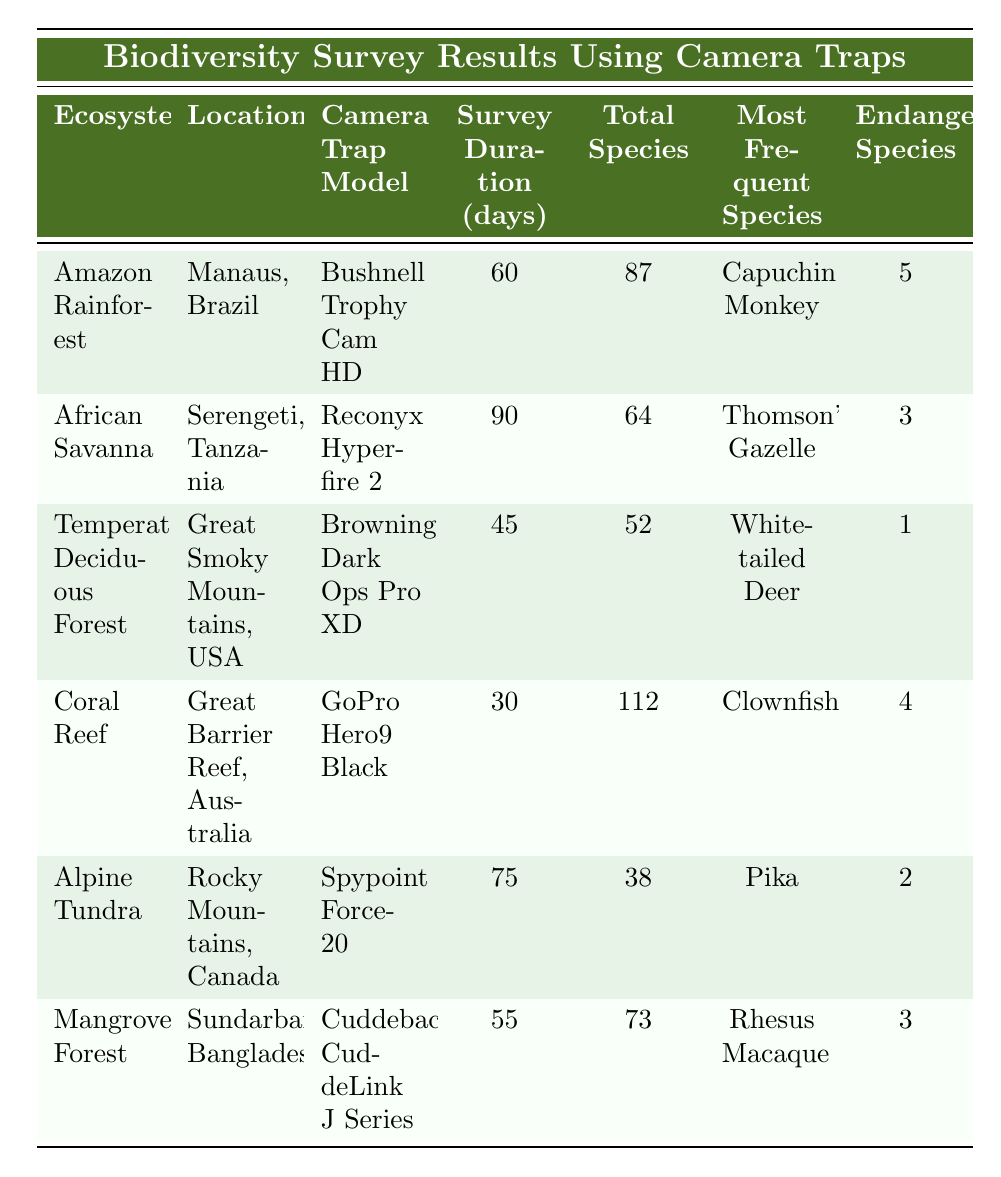What is the total number of species captured in the Coral Reef ecosystem? According to the table, in the Coral Reef ecosystem, the total species captured is listed as 112.
Answer: 112 Which ecosystem had the shortest survey duration? The survey duration for the Alpine Tundra is 75 days, but the Temperate Deciduous Forest had only 45 days, which is the shortest.
Answer: Temperate Deciduous Forest How many endangered species were observed in the Amazon Rainforest? The table states that 5 endangered species were observed in the Amazon Rainforest.
Answer: 5 What is the average number of endangered species observed across all ecosystems? The total observed endangered species are 5 (Amazon Rainforest) + 3 (African Savanna) + 1 (Temperate Deciduous Forest) + 4 (Coral Reef) + 2 (Alpine Tundra) + 3 (Mangrove Forest) = 18. There are 6 ecosystems, so the average is 18/6 = 3.
Answer: 3 Does the Alpine Tundra ecosystem have more mammals or birds captured? The Alpine Tundra captured 22 mammals and 14 birds. Since 22 is greater than 14, mammals are more numerous than birds.
Answer: Yes, more mammals What is the difference in the total species captured between the Amazon Rainforest and the African Savanna? The Amazon Rainforest has 87 species, whereas the African Savanna has 64 species. The difference is 87 - 64 = 23.
Answer: 23 Which ecosystem had the highest count of observed mammals? In the Coral Reef ecosystem, there is no mammal count listed; however, the Amazon Rainforest had 42 mammals, which is the highest number recorded compared to other ecosystems in the table.
Answer: Amazon Rainforest If we add the total species captured in the Temperate Deciduous Forest and the Mangrove Forest, what do we get? The Temperate Deciduous Forest captured 52 species, and the Mangrove Forest captured 73 species. Adding them together gives us 52 + 73 = 125.
Answer: 125 How many species were captured in the Great Smoky Mountains compared to the Great Barrier Reef? The Great Smoky Mountains captured 52 species, while the Great Barrier Reef captured 112 species. Comparing these, the Great Barrier Reef captured more species.
Answer: Great Barrier Reef had more What is the most frequent species observed in the African Savanna? The table indicates that the most frequent species in the African Savanna is Thomson's Gazelle.
Answer: Thomson's Gazelle 